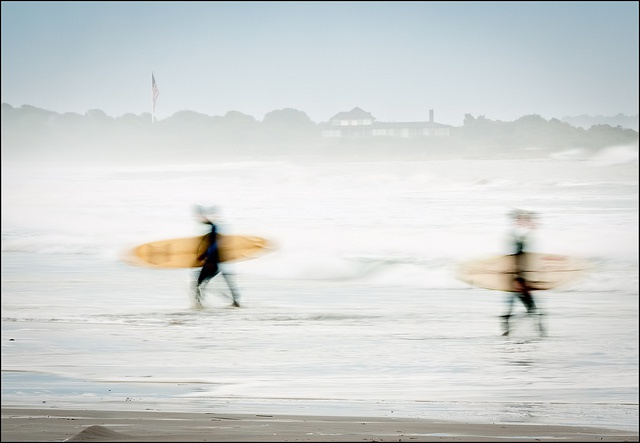Describe the objects in this image and their specific colors. I can see surfboard in black, lightgray, and tan tones, surfboard in black, tan, and lightgray tones, people in black, darkgray, lightgray, and gray tones, and people in black, lightgray, darkgray, and olive tones in this image. 